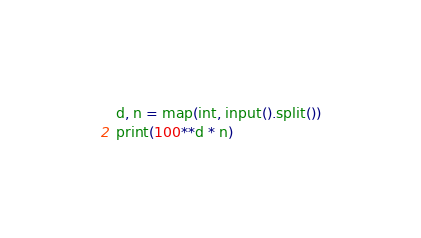Convert code to text. <code><loc_0><loc_0><loc_500><loc_500><_Python_>d, n = map(int, input().split())
print(100**d * n)
</code> 